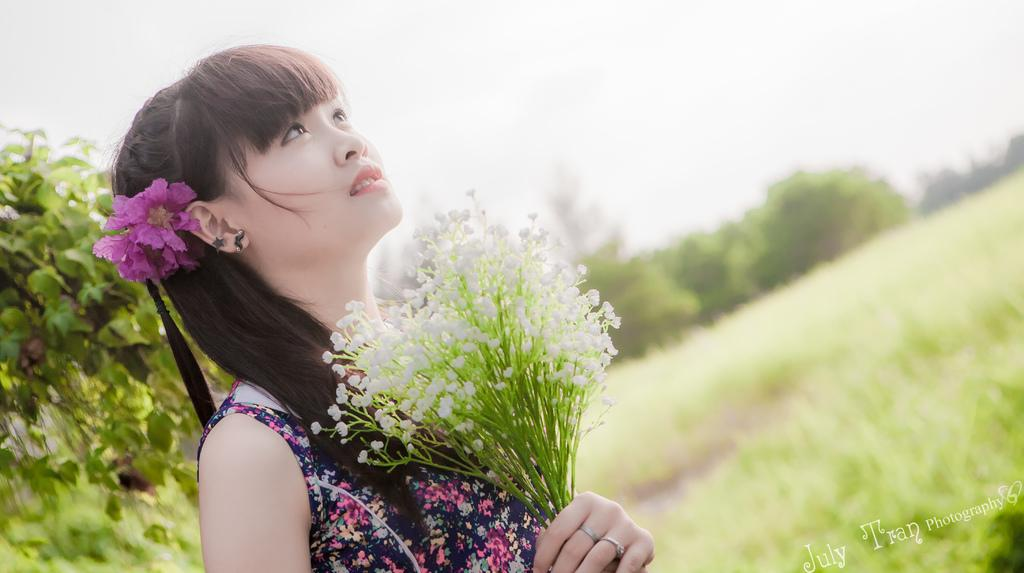Who is the main subject in the image? There is a girl in the image. What is the girl's posture in the image? The girl is facing upright in the image. What is the girl holding in her hand? The girl is holding a bunch of flowers in her hand. Can you describe the background of the image? The background of the image is blurry. What type of beef is being cooked in the image? There is no beef present in the image; it features a girl holding a bunch of flowers. How many toes can be seen on the girl's foot in the image? The image does not show the girl's foot, so the number of toes cannot be determined. 